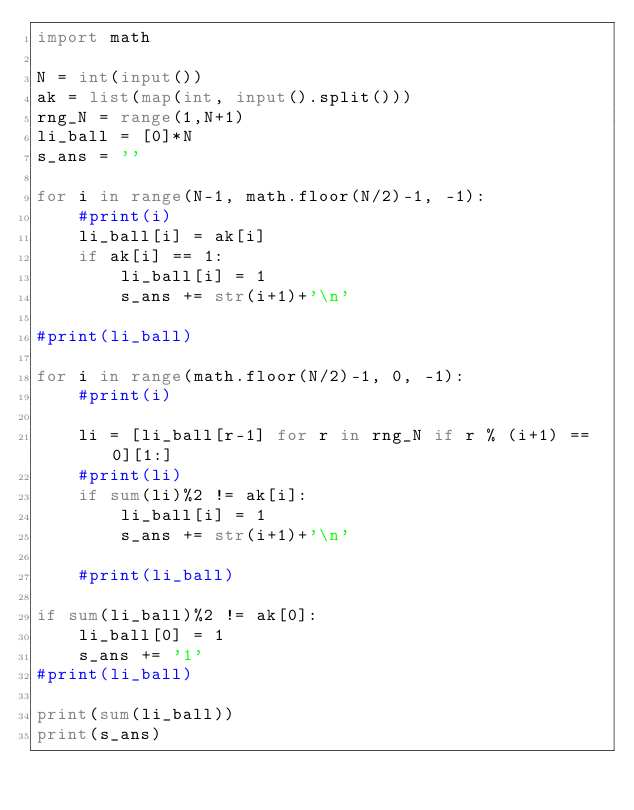Convert code to text. <code><loc_0><loc_0><loc_500><loc_500><_Python_>import math

N = int(input())
ak = list(map(int, input().split()))
rng_N = range(1,N+1)
li_ball = [0]*N 
s_ans = ''

for i in range(N-1, math.floor(N/2)-1, -1):
    #print(i)
    li_ball[i] = ak[i]
    if ak[i] == 1:
        li_ball[i] = 1
        s_ans += str(i+1)+'\n'
    
#print(li_ball)

for i in range(math.floor(N/2)-1, 0, -1):
    #print(i)
    
    li = [li_ball[r-1] for r in rng_N if r % (i+1) == 0][1:]
    #print(li)
    if sum(li)%2 != ak[i]:
        li_ball[i] = 1
        s_ans += str(i+1)+'\n'
        
    #print(li_ball)
    
if sum(li_ball)%2 != ak[0]:   
    li_ball[0] = 1
    s_ans += '1'
#print(li_ball)

print(sum(li_ball))
print(s_ans)
</code> 